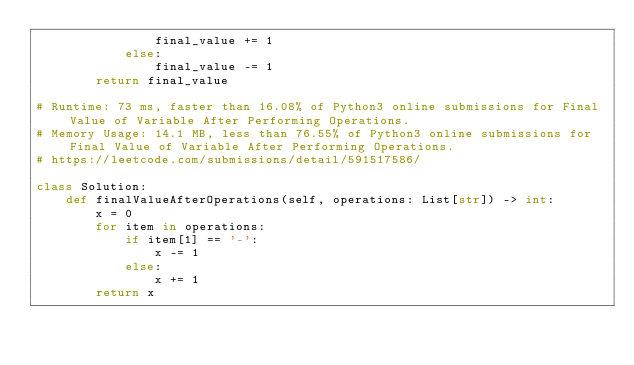Convert code to text. <code><loc_0><loc_0><loc_500><loc_500><_Python_>                final_value += 1
            else:
                final_value -= 1
        return final_value

# Runtime: 73 ms, faster than 16.08% of Python3 online submissions for Final Value of Variable After Performing Operations.
# Memory Usage: 14.1 MB, less than 76.55% of Python3 online submissions for Final Value of Variable After Performing Operations.
# https://leetcode.com/submissions/detail/591517586/

class Solution:
    def finalValueAfterOperations(self, operations: List[str]) -> int:
        x = 0
        for item in operations:
            if item[1] == '-':
                x -= 1
            else:
                x += 1
        return x
</code> 